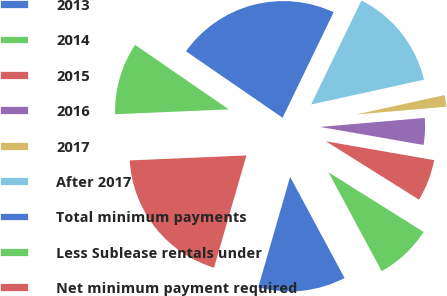Convert chart. <chart><loc_0><loc_0><loc_500><loc_500><pie_chart><fcel>2013<fcel>2014<fcel>2015<fcel>2016<fcel>2017<fcel>After 2017<fcel>Total minimum payments<fcel>Less Sublease rentals under<fcel>Net minimum payment required<nl><fcel>12.33%<fcel>8.22%<fcel>6.17%<fcel>4.12%<fcel>2.07%<fcel>14.38%<fcel>22.58%<fcel>10.27%<fcel>19.85%<nl></chart> 